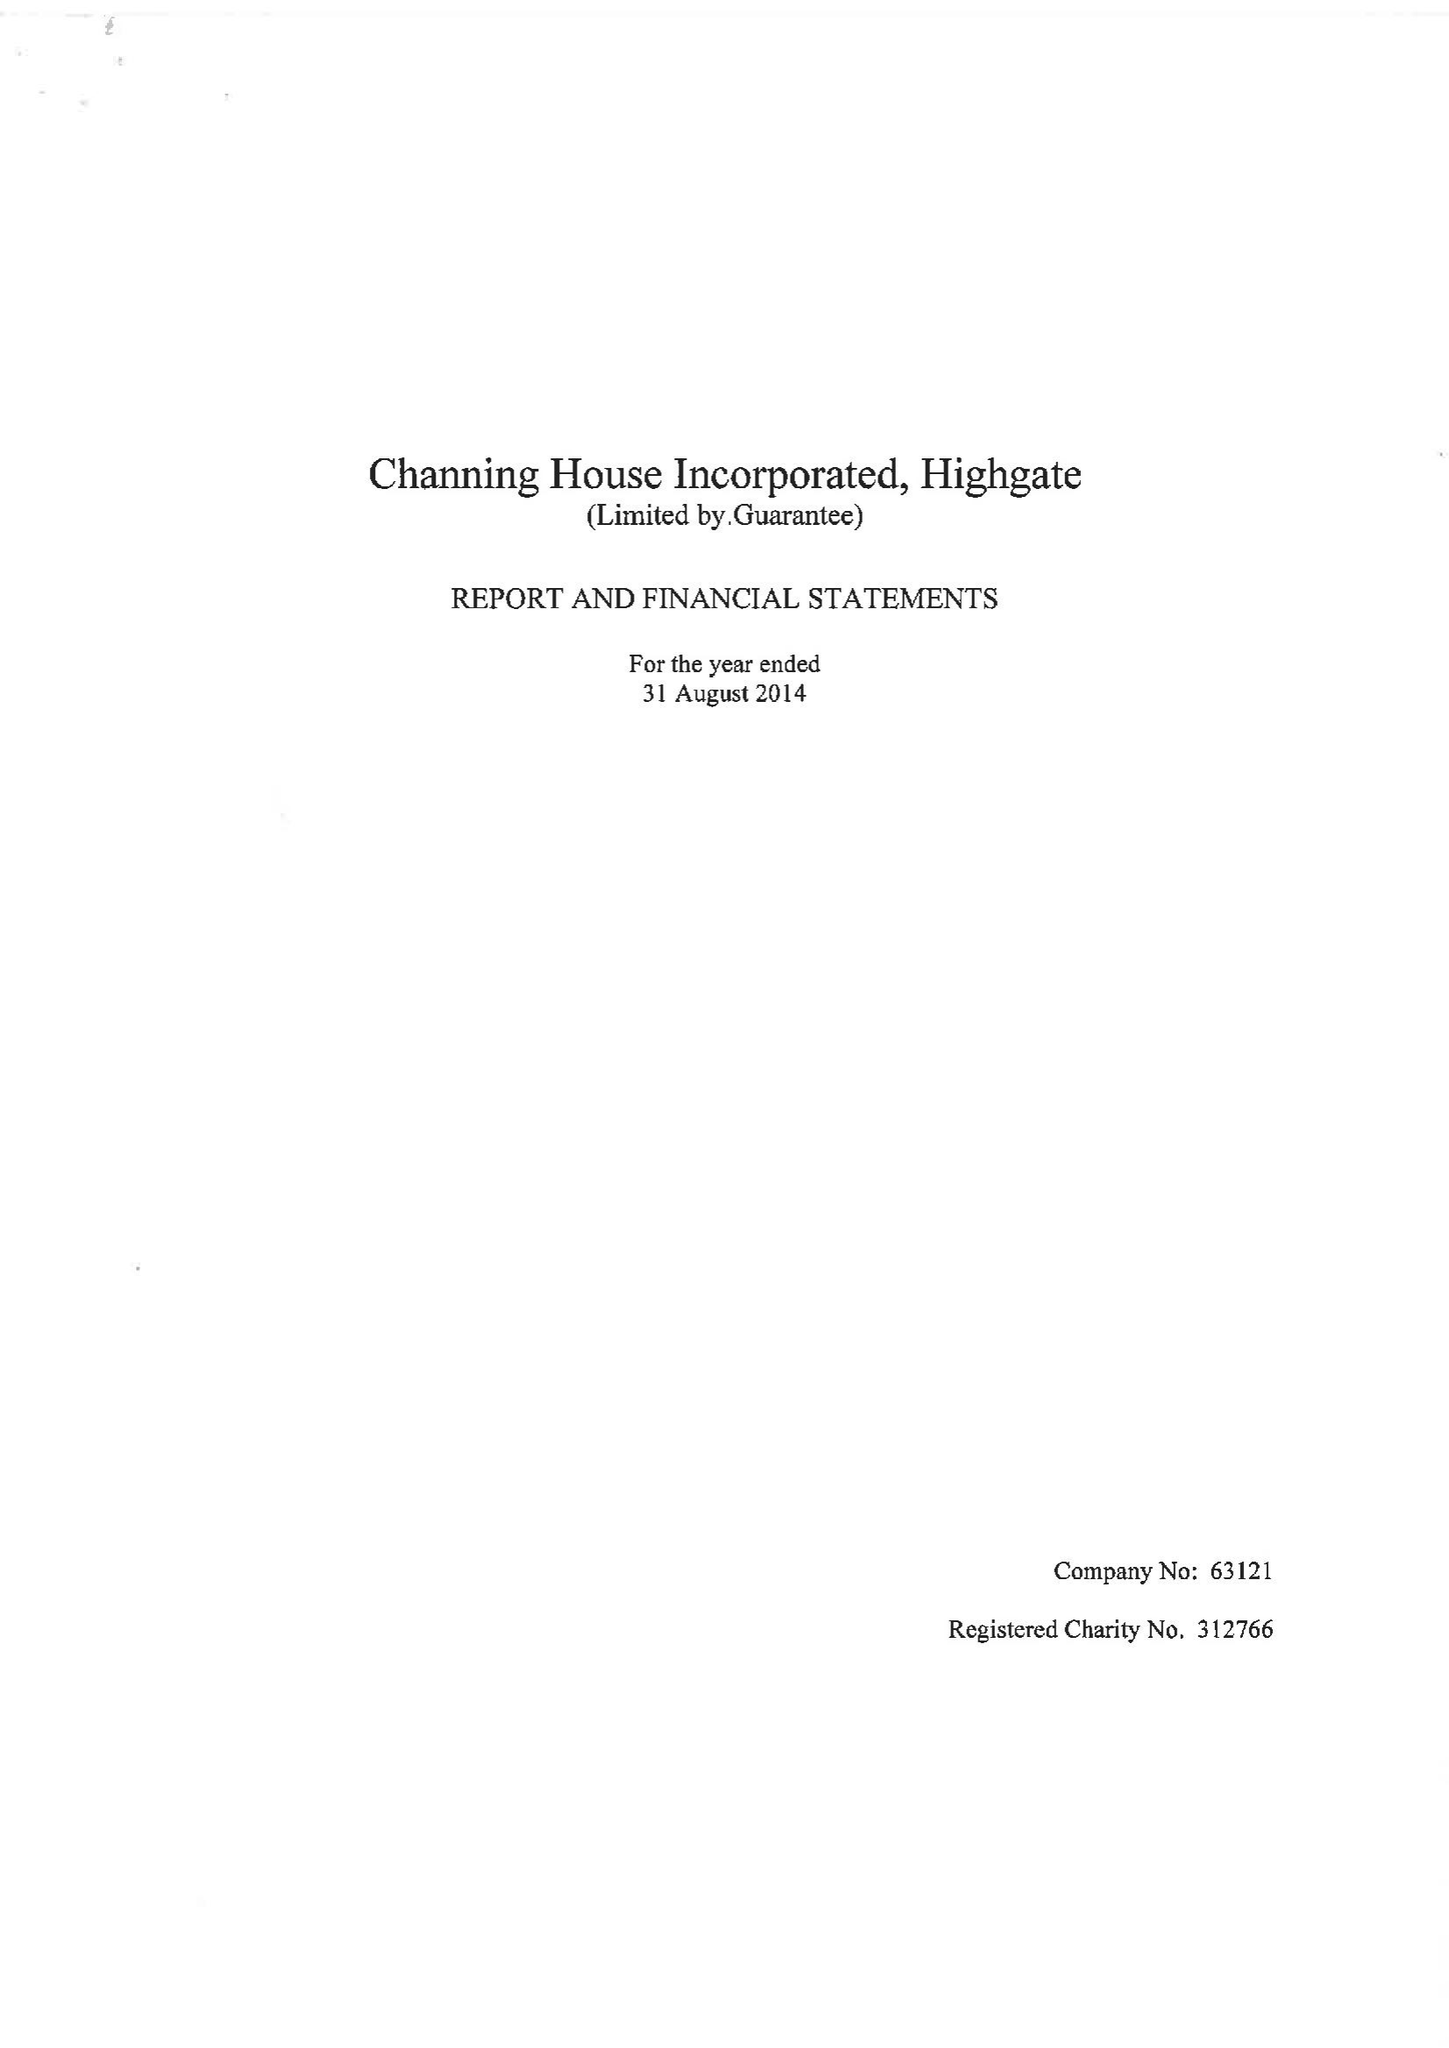What is the value for the address__post_town?
Answer the question using a single word or phrase. LONDON 